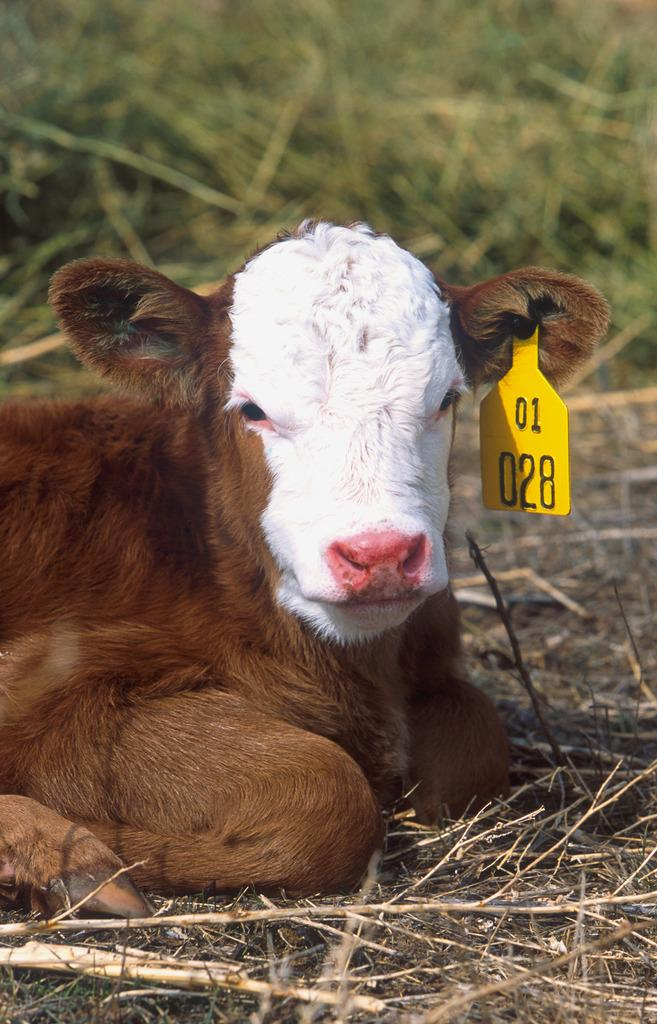What is the main subject in the center of the image? There is a cow in the center of the image. Can you describe the position of the cow in the image? The cow is on the ground in the image. What type of vegetation is visible in the background of the image? There is grass visible in the background of the image. What type of bells can be heard ringing in the image? There are no bells present in the image, and therefore no such sound can be heard. What type of selection process is taking place in the image? There is no selection process taking place in the image. Where is the mailbox located in the image? There is no mailbox present in the image. 